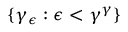Convert formula to latex. <formula><loc_0><loc_0><loc_500><loc_500>\{ \gamma _ { \epsilon } \colon \epsilon < \gamma ^ { \gamma } \}</formula> 